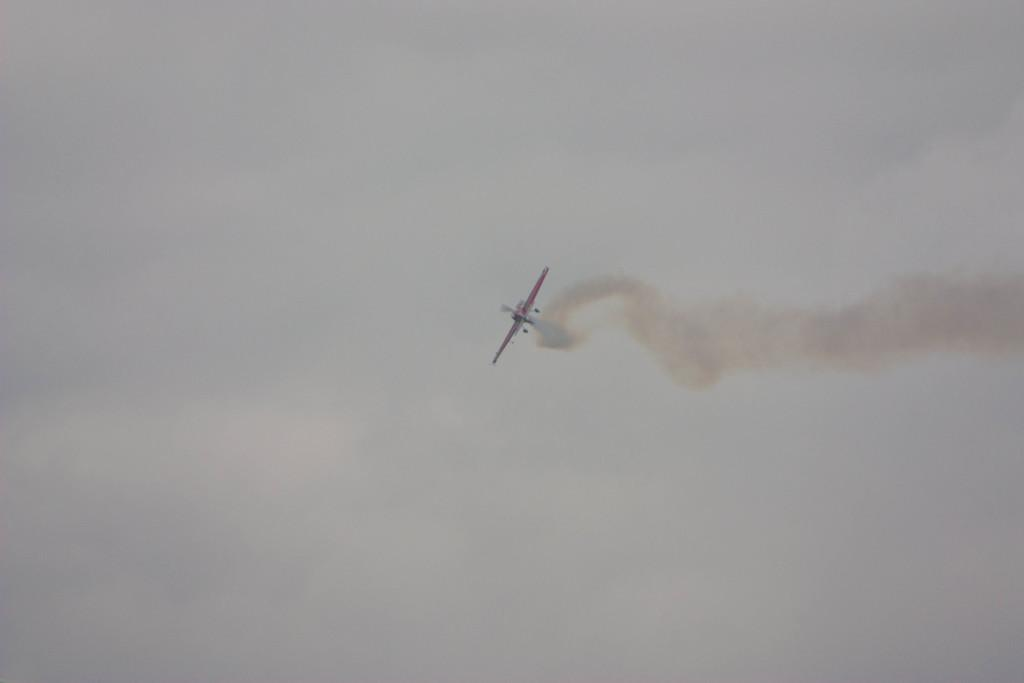What is the main subject of the image? The main subject of the image is an airplane. Where is the airplane located in the image? The airplane is in the middle of the image. What can be seen in the background of the image? The sky is visible in the background of the image. What type of shirt is the bee wearing in the image? There is no bee or shirt present in the image. 